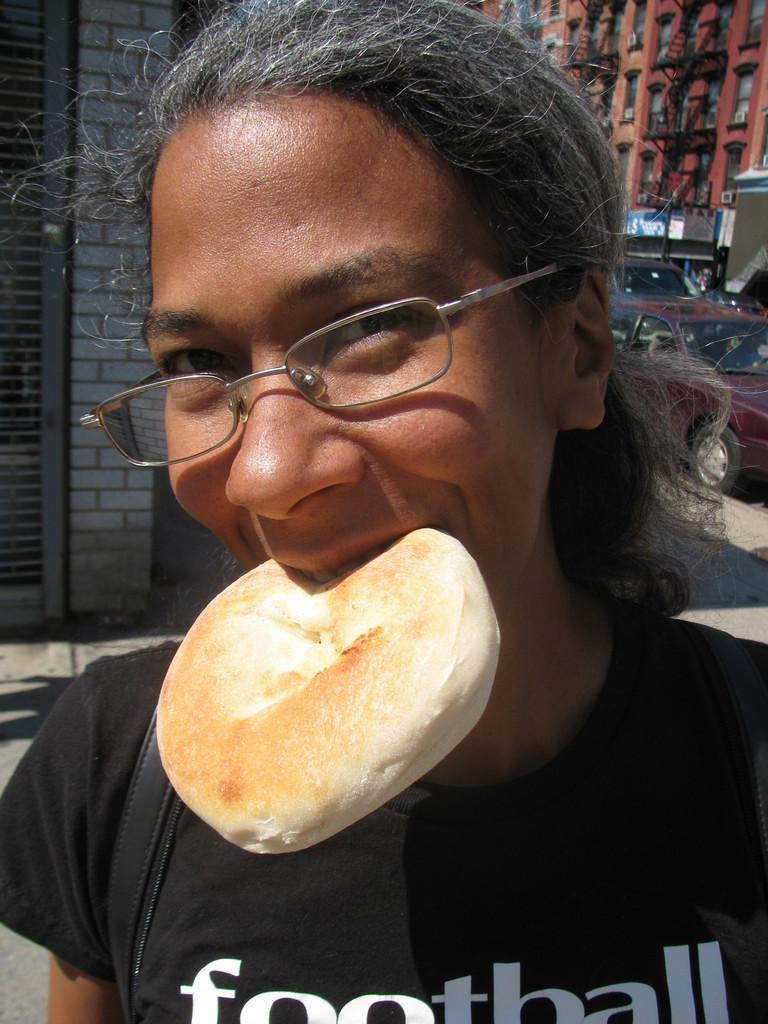Who is the main subject in the image? There is a woman in the image. What is the woman doing with the bun? The woman is holding a bun in her mouth. What can be seen on the woman's face? The woman is wearing spectacles. What is the woman wearing on her upper body? The woman is wearing a black color t-shirt. What can be seen in the distance behind the woman? There are buildings visible in the background of the image, along with other objects. What type of arch can be seen in the image? There is no arch present in the image. How many rays of light are visible in the image? There are no rays of light visible in the image. 